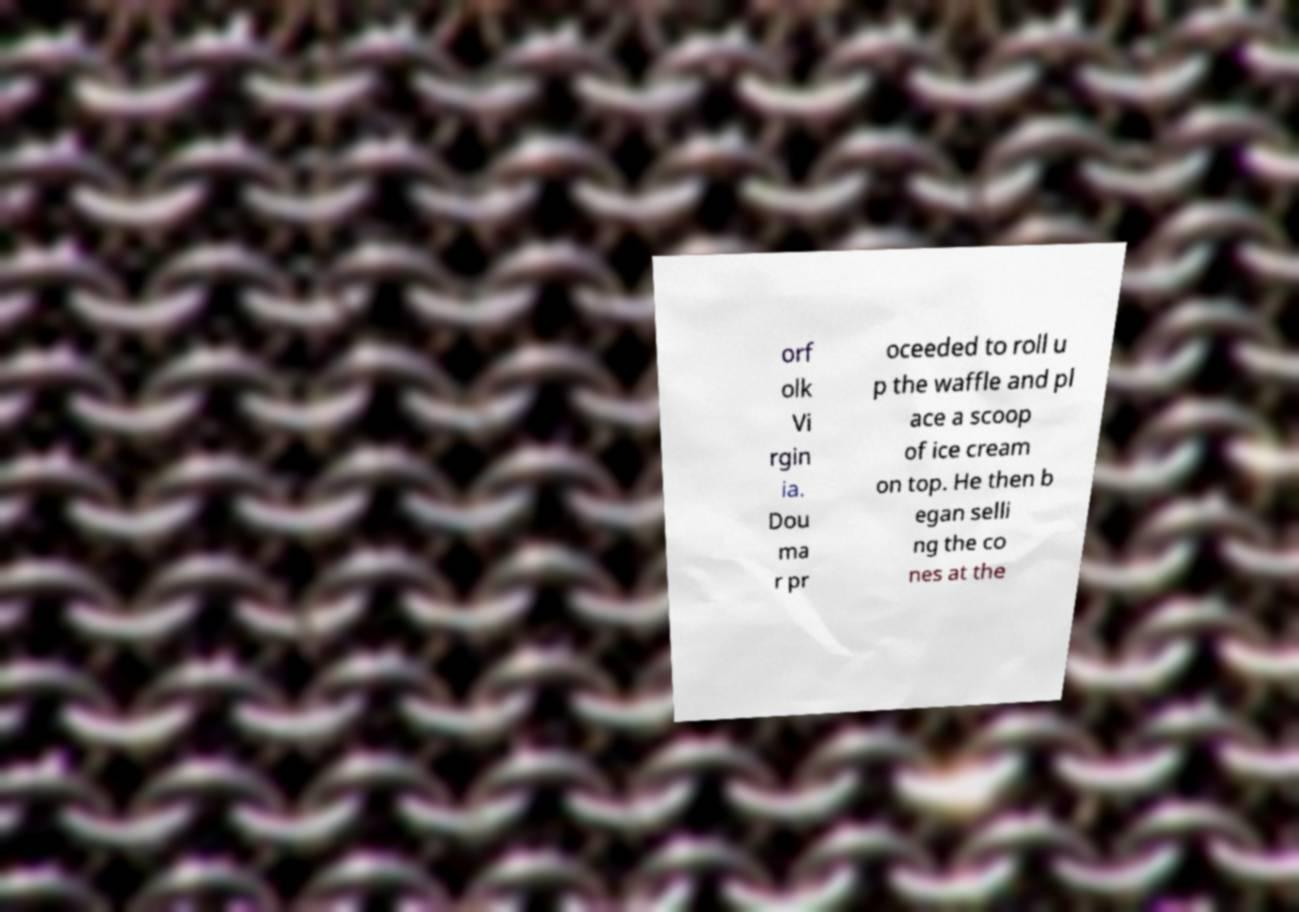What messages or text are displayed in this image? I need them in a readable, typed format. orf olk Vi rgin ia. Dou ma r pr oceeded to roll u p the waffle and pl ace a scoop of ice cream on top. He then b egan selli ng the co nes at the 